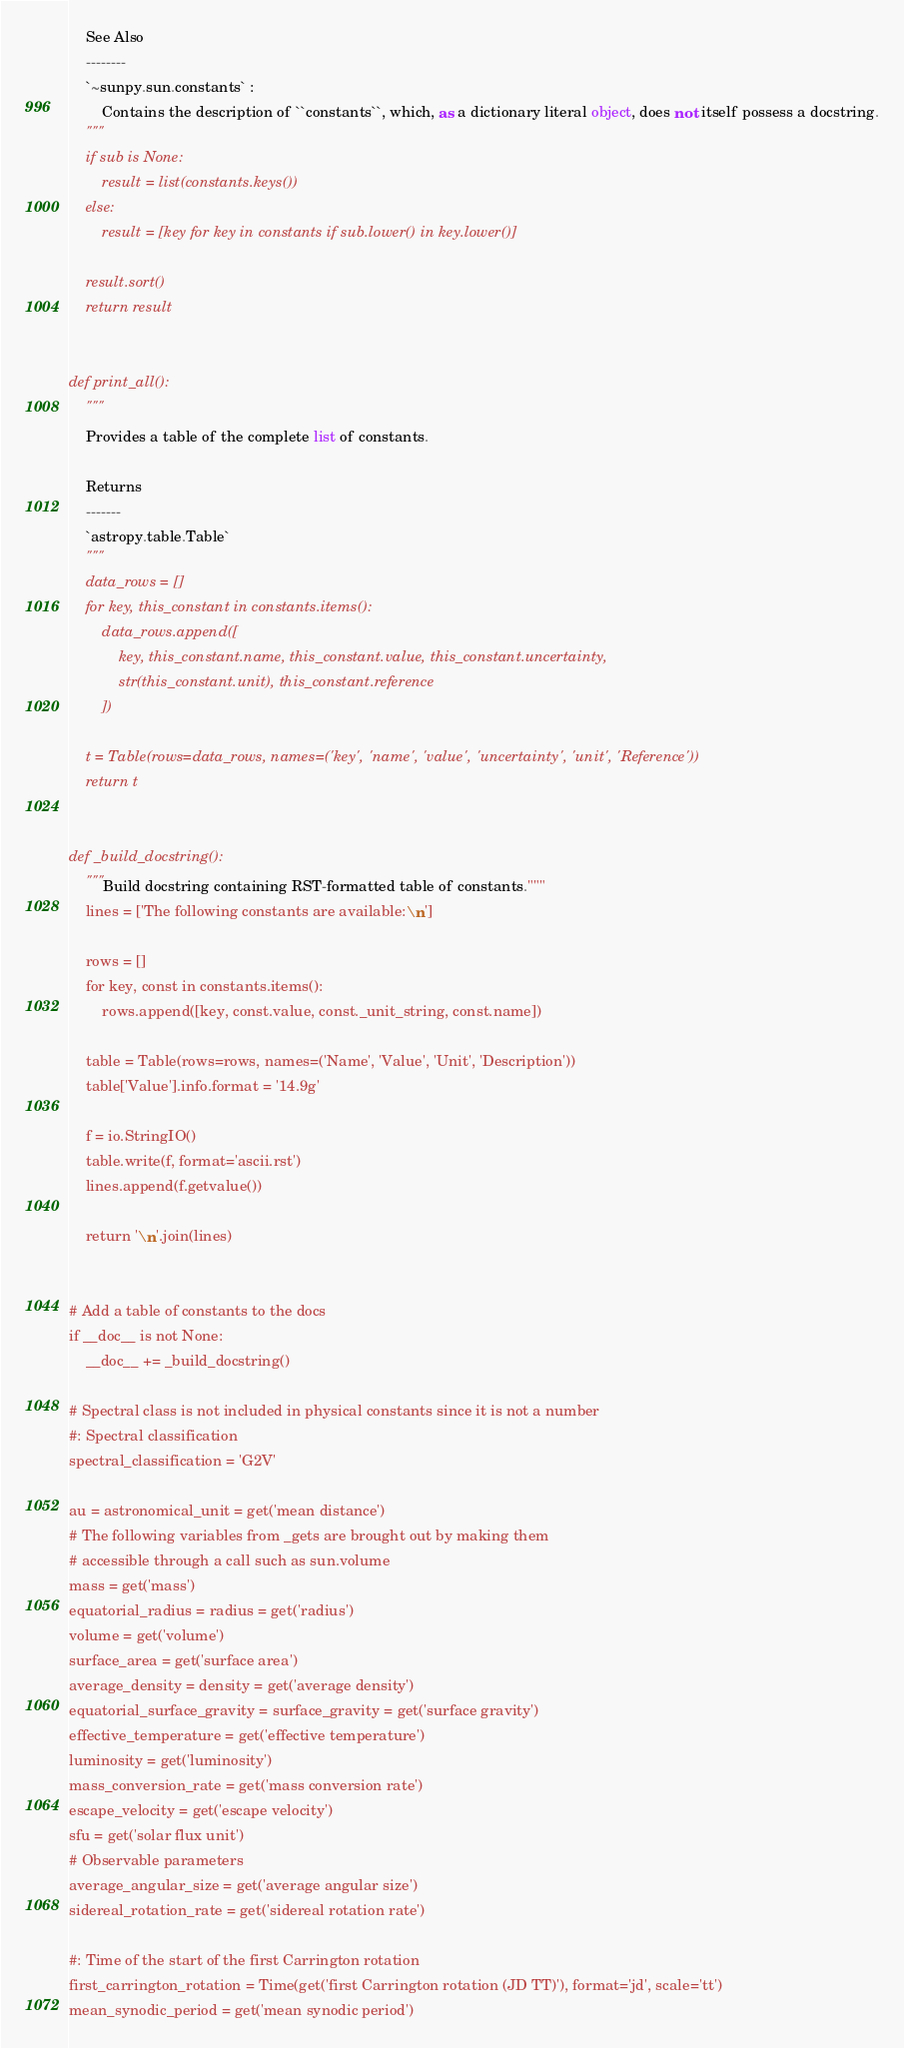Convert code to text. <code><loc_0><loc_0><loc_500><loc_500><_Python_>    See Also
    --------
    `~sunpy.sun.constants` :
        Contains the description of ``constants``, which, as a dictionary literal object, does not itself possess a docstring.
    """
    if sub is None:
        result = list(constants.keys())
    else:
        result = [key for key in constants if sub.lower() in key.lower()]

    result.sort()
    return result


def print_all():
    """
    Provides a table of the complete list of constants.

    Returns
    -------
    `astropy.table.Table`
    """
    data_rows = []
    for key, this_constant in constants.items():
        data_rows.append([
            key, this_constant.name, this_constant.value, this_constant.uncertainty,
            str(this_constant.unit), this_constant.reference
        ])

    t = Table(rows=data_rows, names=('key', 'name', 'value', 'uncertainty', 'unit', 'Reference'))
    return t


def _build_docstring():
    """Build docstring containing RST-formatted table of constants."""
    lines = ['The following constants are available:\n']

    rows = []
    for key, const in constants.items():
        rows.append([key, const.value, const._unit_string, const.name])

    table = Table(rows=rows, names=('Name', 'Value', 'Unit', 'Description'))
    table['Value'].info.format = '14.9g'

    f = io.StringIO()
    table.write(f, format='ascii.rst')
    lines.append(f.getvalue())

    return '\n'.join(lines)


# Add a table of constants to the docs
if __doc__ is not None:
    __doc__ += _build_docstring()

# Spectral class is not included in physical constants since it is not a number
#: Spectral classification
spectral_classification = 'G2V'

au = astronomical_unit = get('mean distance')
# The following variables from _gets are brought out by making them
# accessible through a call such as sun.volume
mass = get('mass')
equatorial_radius = radius = get('radius')
volume = get('volume')
surface_area = get('surface area')
average_density = density = get('average density')
equatorial_surface_gravity = surface_gravity = get('surface gravity')
effective_temperature = get('effective temperature')
luminosity = get('luminosity')
mass_conversion_rate = get('mass conversion rate')
escape_velocity = get('escape velocity')
sfu = get('solar flux unit')
# Observable parameters
average_angular_size = get('average angular size')
sidereal_rotation_rate = get('sidereal rotation rate')

#: Time of the start of the first Carrington rotation
first_carrington_rotation = Time(get('first Carrington rotation (JD TT)'), format='jd', scale='tt')
mean_synodic_period = get('mean synodic period')
</code> 